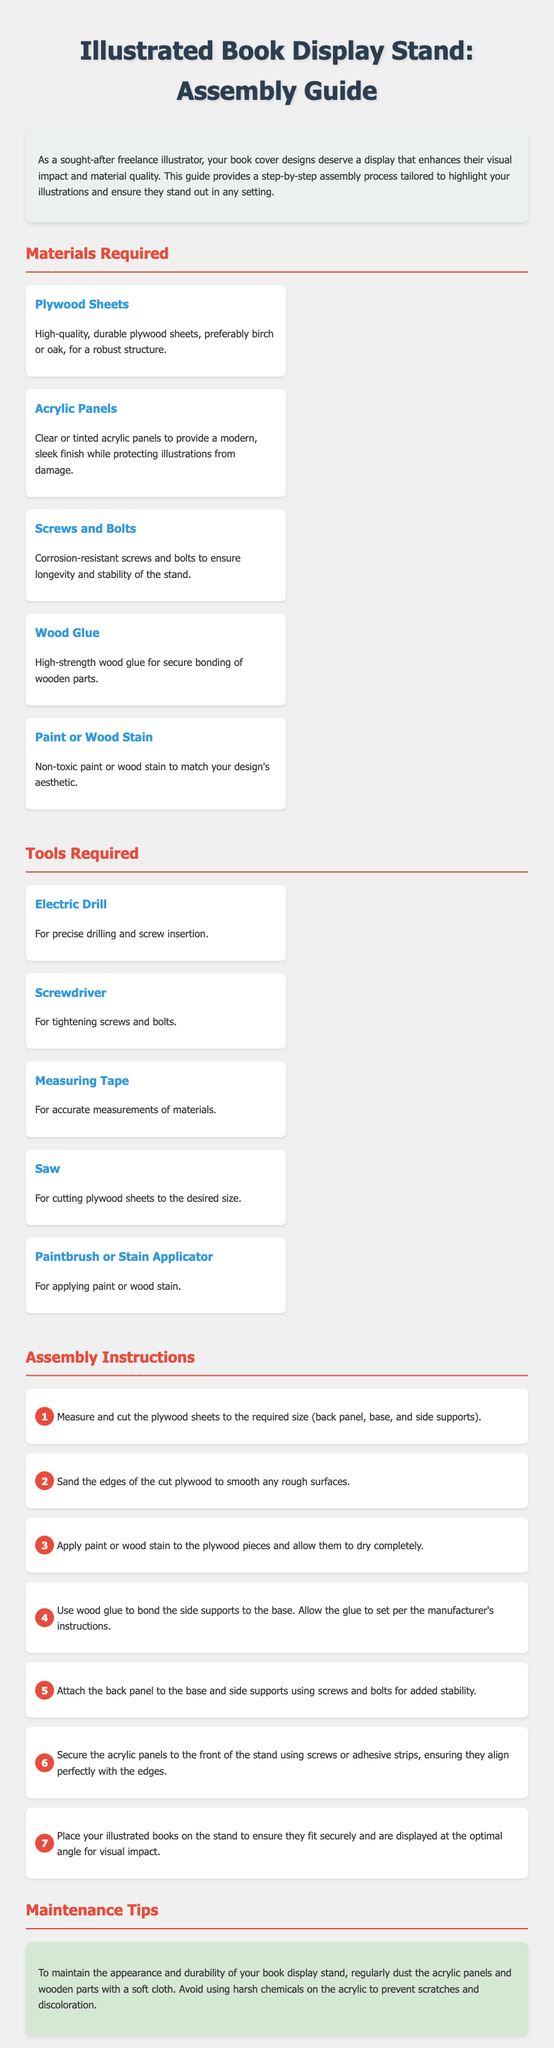What type of wood is recommended for the stand? The document specifies high-quality, durable plywood sheets, preferably birch or oak.
Answer: Birch or oak What is the purpose of acrylic panels in the display stand? Acrylic panels provide a modern, sleek finish while protecting illustrations from damage.
Answer: Protection How many screws and bolts are needed for the assembly? The document does not specify a number, but indicates the need for corrosion-resistant screws and bolts for stability.
Answer: Not specified What tool is used for precise drilling? The electric drill is specified for precise drilling and screw insertion.
Answer: Electric drill What is the first step in the assembly instructions? The first step is to measure and cut the plywood sheets to the required size.
Answer: Measure and cut What should be applied to plywood before assembly? The document states that paint or wood stain should be applied to the plywood pieces.
Answer: Paint or wood stain How should the acrylic panels be secured to the stand? Acrylic panels should be secured to the front of the stand using screws or adhesive strips.
Answer: Screws or adhesive strips What is the maintenance recommendation for the stand? The maintenance tip recommends regularly dusting the acrylic panels and wooden parts with a soft cloth.
Answer: Regularly dusting What color theme is prominent in the document design? The document features a color theme with blue and red prominently used for headings.
Answer: Blue and red 